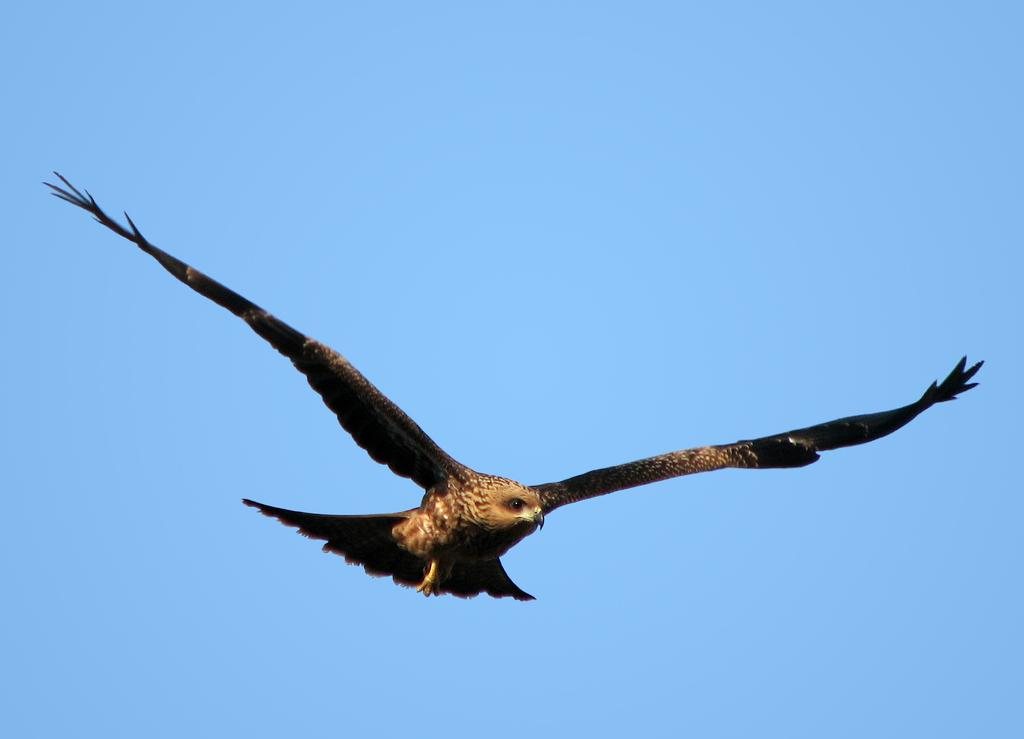What animal can be seen in the image? There is an eagle in the image. What is the eagle doing in the image? The eagle is flying in the air. What can be seen in the background of the image? The sky is visible in the image. What is the color of the sky in the image? The sky is blue in color. What type of waste can be seen on the ground in the image? There is no waste present on the ground in the image; it only features an eagle flying in the sky. What substance is the eagle made of in the image? The eagle is a living creature made of flesh, bones, and feathers, not a substance. 